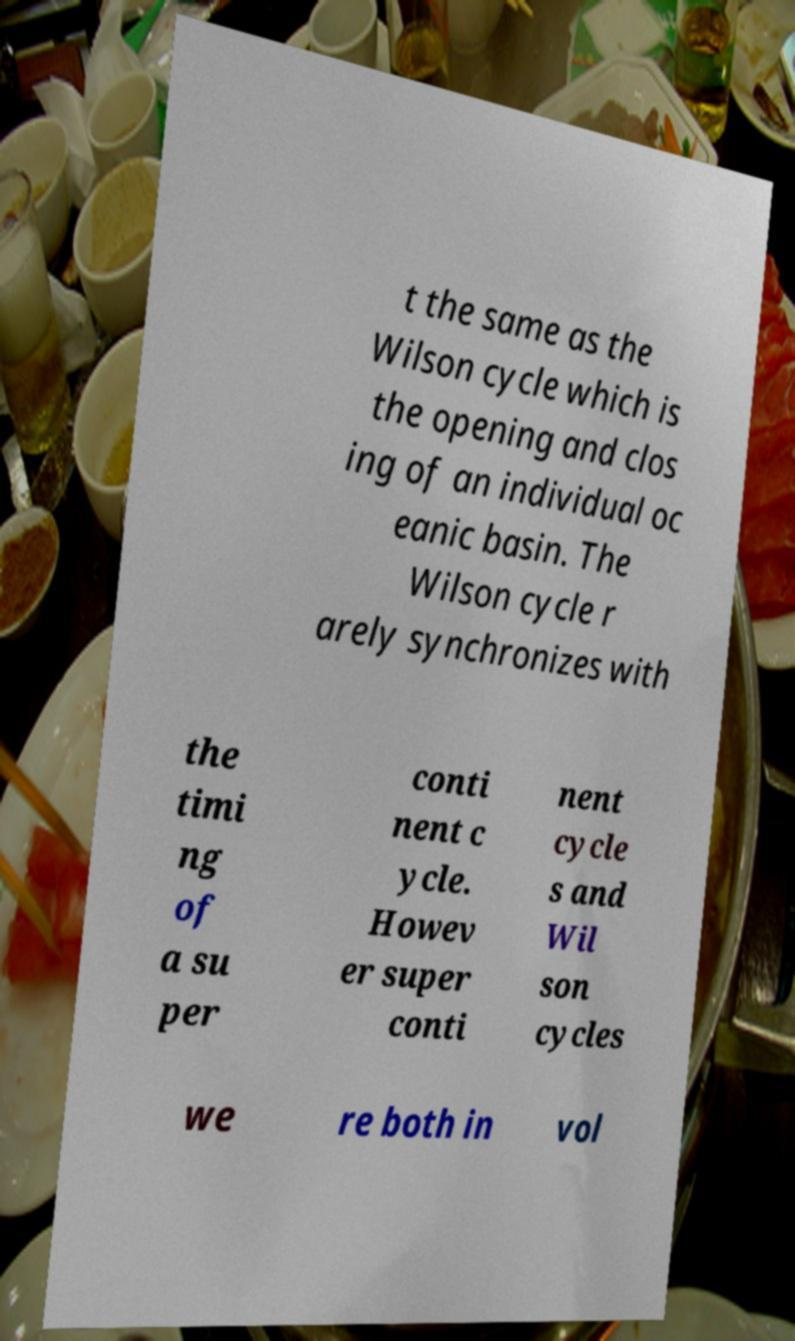For documentation purposes, I need the text within this image transcribed. Could you provide that? t the same as the Wilson cycle which is the opening and clos ing of an individual oc eanic basin. The Wilson cycle r arely synchronizes with the timi ng of a su per conti nent c ycle. Howev er super conti nent cycle s and Wil son cycles we re both in vol 